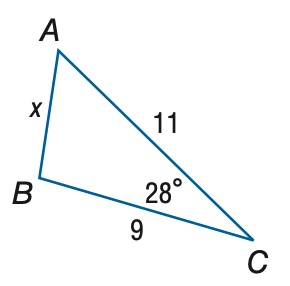Question: Find x. Round to the nearest tenth.
Choices:
A. 2.6
B. 5.2
C. 10.4
D. 27.2
Answer with the letter. Answer: B 